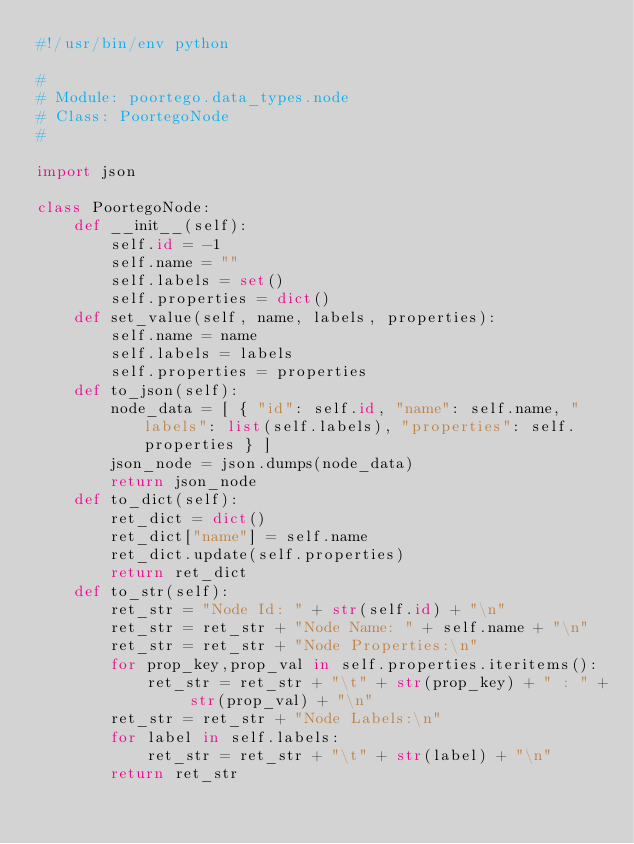<code> <loc_0><loc_0><loc_500><loc_500><_Python_>#!/usr/bin/env python

#
# Module: poortego.data_types.node
# Class: PoortegoNode
#

import json

class PoortegoNode:
    def __init__(self):
        self.id = -1
        self.name = ""
        self.labels = set()
        self.properties = dict()
    def set_value(self, name, labels, properties):
        self.name = name
        self.labels = labels
        self.properties = properties
    def to_json(self):
        node_data = [ { "id": self.id, "name": self.name, "labels": list(self.labels), "properties": self.properties } ]
        json_node = json.dumps(node_data)
        return json_node
    def to_dict(self):
        ret_dict = dict()
        ret_dict["name"] = self.name
        ret_dict.update(self.properties)
        return ret_dict
    def to_str(self):
        ret_str = "Node Id: " + str(self.id) + "\n"
        ret_str = ret_str + "Node Name: " + self.name + "\n"    
        ret_str = ret_str + "Node Properties:\n"
        for prop_key,prop_val in self.properties.iteritems():
            ret_str = ret_str + "\t" + str(prop_key) + " : " + str(prop_val) + "\n"
        ret_str = ret_str + "Node Labels:\n"
        for label in self.labels:
            ret_str = ret_str + "\t" + str(label) + "\n"
        return ret_str</code> 